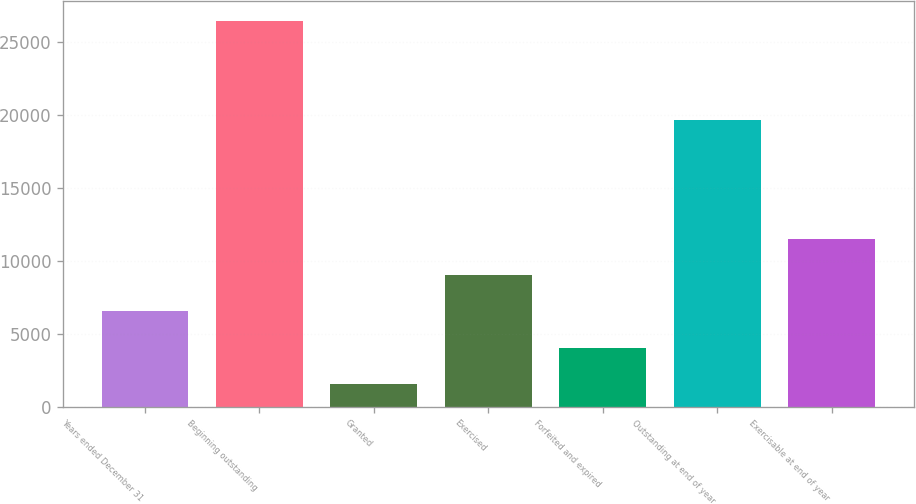Convert chart. <chart><loc_0><loc_0><loc_500><loc_500><bar_chart><fcel>Years ended December 31<fcel>Beginning outstanding<fcel>Granted<fcel>Exercised<fcel>Forfeited and expired<fcel>Outstanding at end of year<fcel>Exercisable at end of year<nl><fcel>6527<fcel>26479<fcel>1539<fcel>9021<fcel>4033<fcel>19666<fcel>11515<nl></chart> 